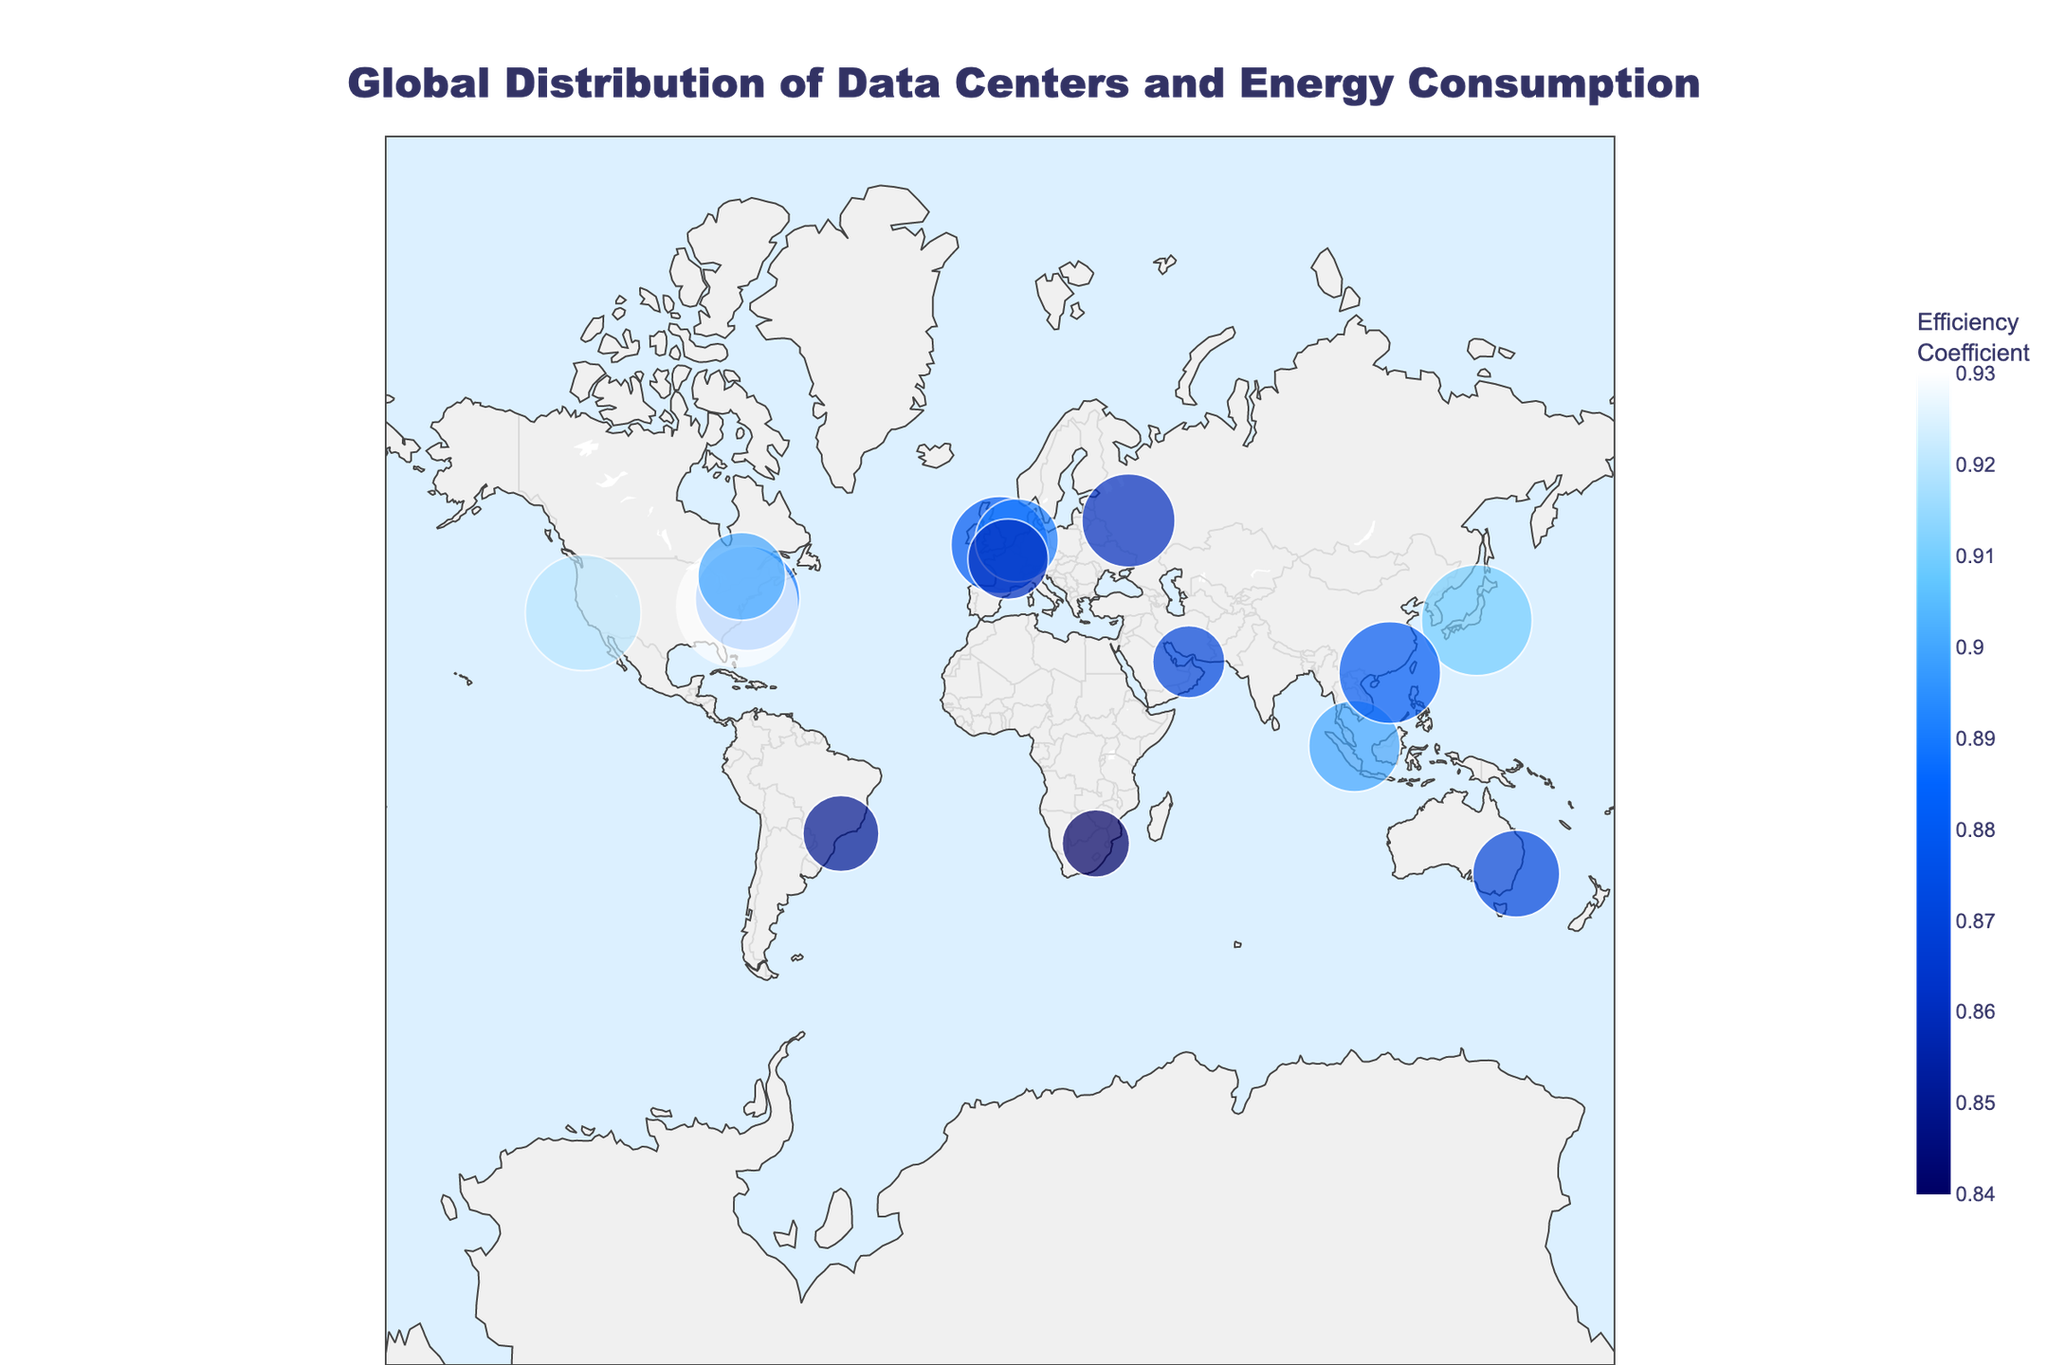How many data centers are represented in the figure? Count the number of distinct data points (each point represents a data center) in the figure.
Answer: 15 Which data center has the highest energy consumption? Look for the data center with the largest size marker in the figure, indicating the highest energy consumption.
Answer: Microsoft Boydton What is the range of the Efficiency Coefficient in the figure? Identify the minimum and maximum Efficiency Coefficient values from the color bar or the color coding of the markers.
Answer: 0.84 to 0.93 Which region (continent) has the highest concentration of data centers? Observe the geographic distribution of the data centers on the map and identify the region with the most data centers.
Answer: North America What is the average energy consumption of the data centers in Asia? Identify the data centers in Asia (NTT Tokyo, Amazon Singapore, and China Mobile Hong Kong), sum their energy consumption, and divide by the number of data centers. (1100000 + 750000 + 930000) / 3 = 926666.67
Answer: 926666.67 MWh/year 